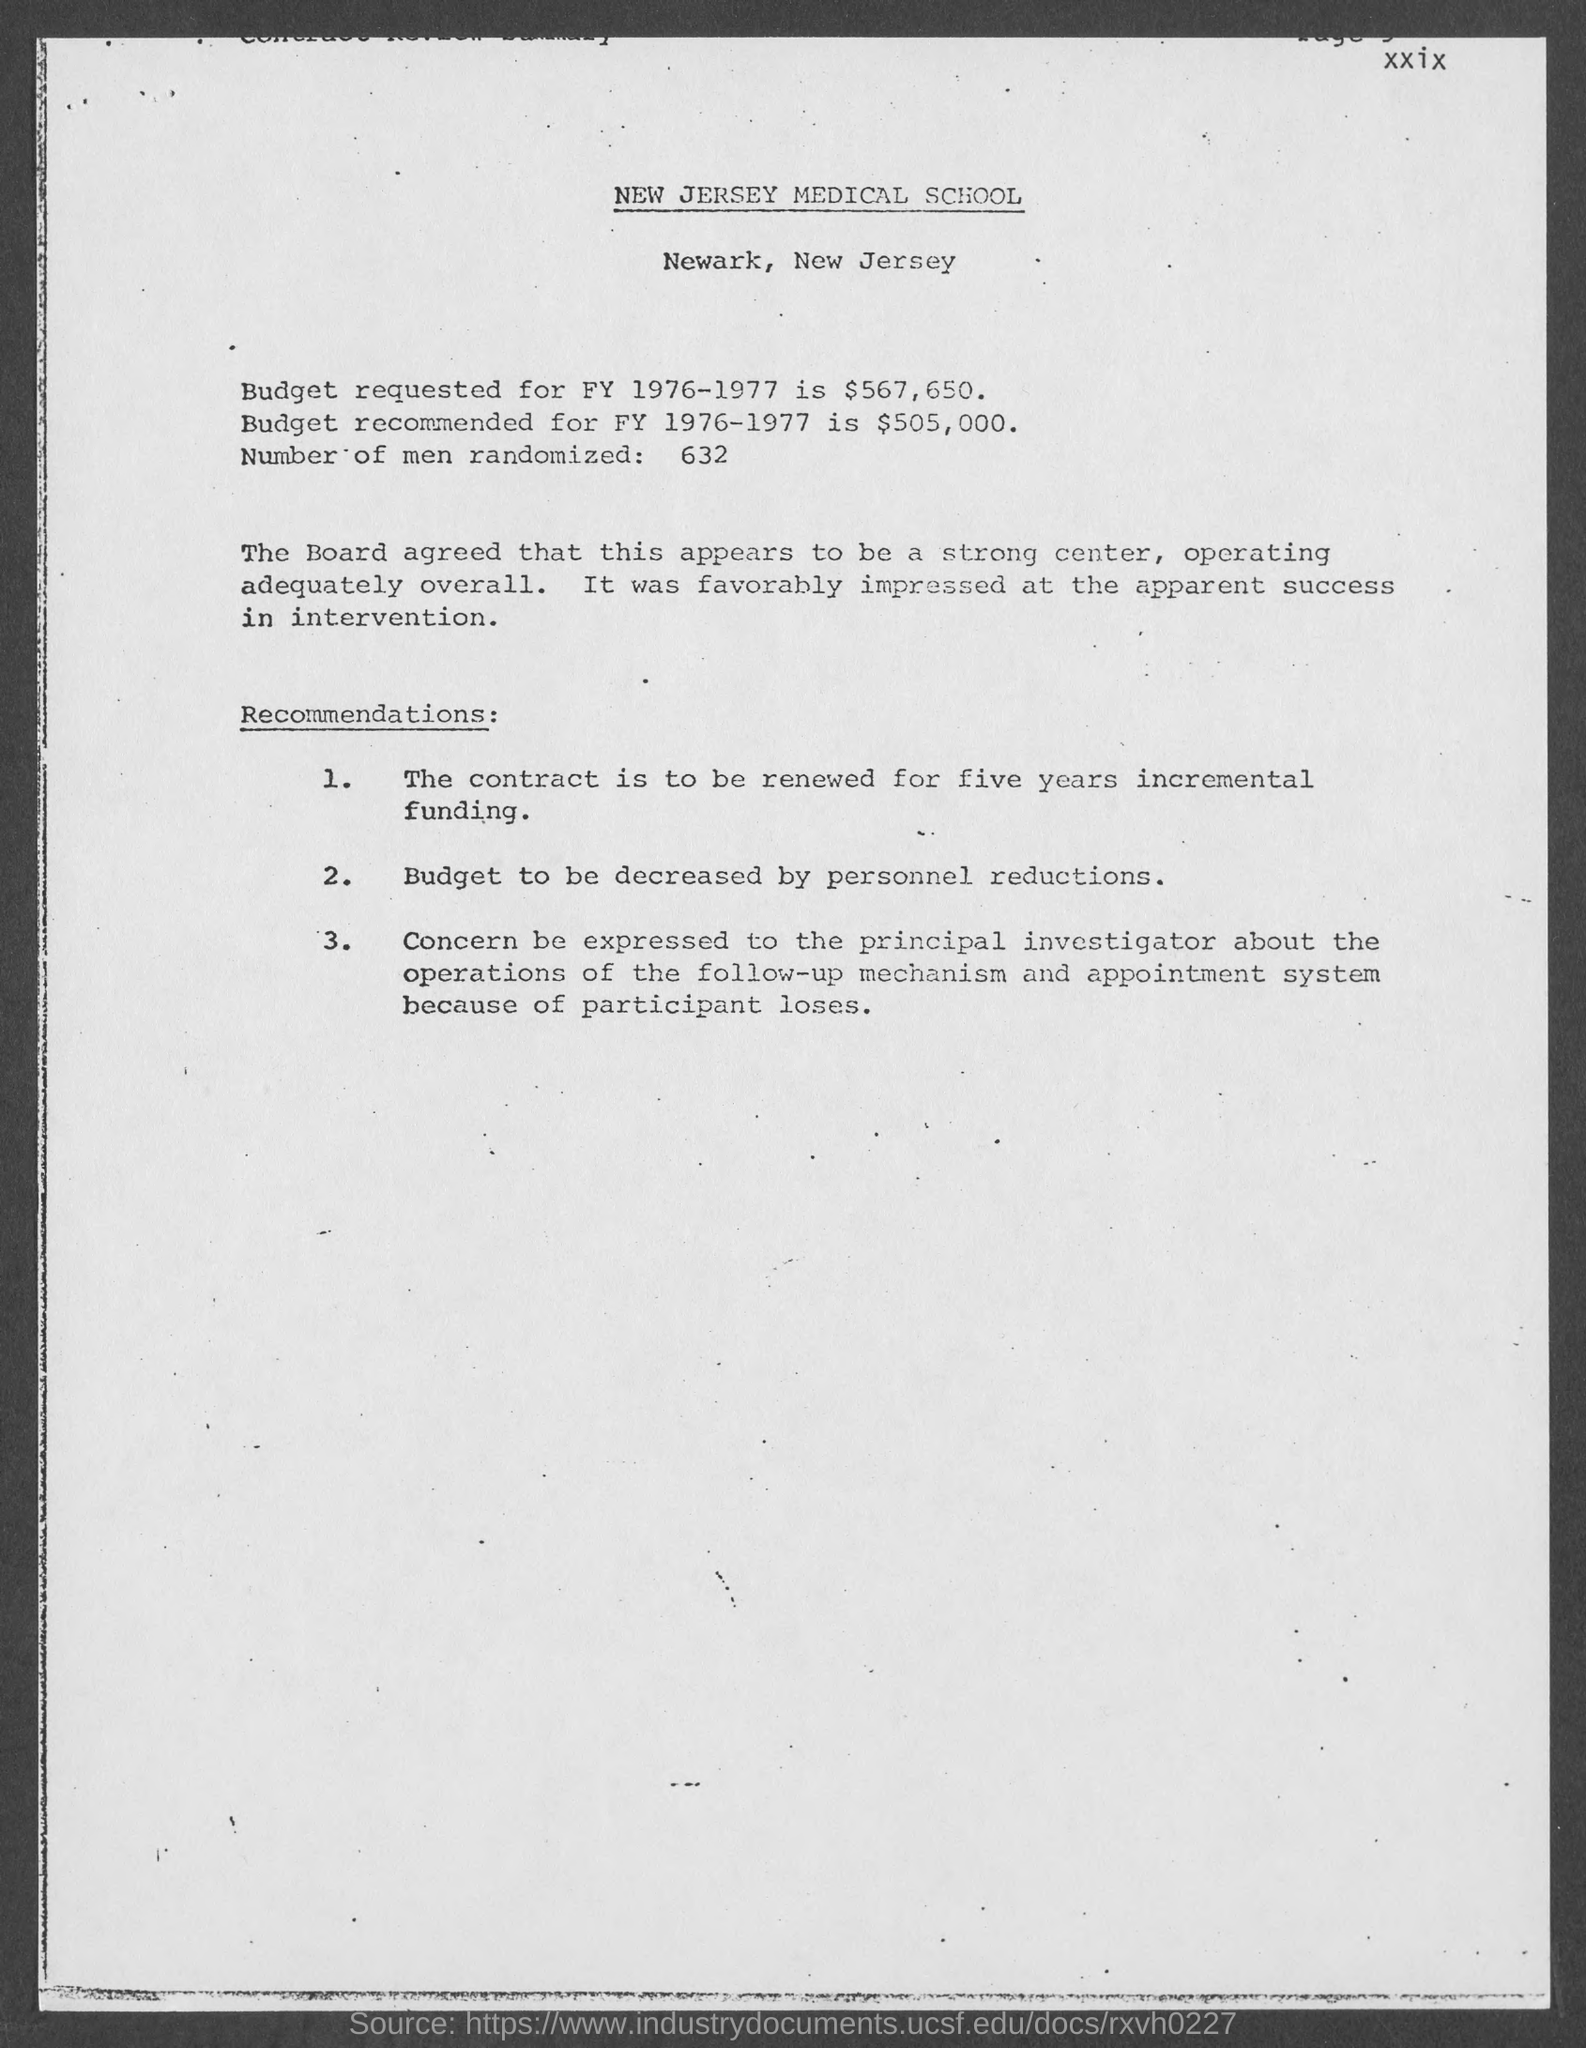List a handful of essential elements in this visual. The document mentions New Jersey Medical School in its header. The board was favorably impressed by the apparent success of the intervention. The number of men randomized is 632, according to the document. The budget requested for Fiscal Year 1976-1977 is $567,650. The recommended budget for fiscal year 1976-1977 is 505,000... 